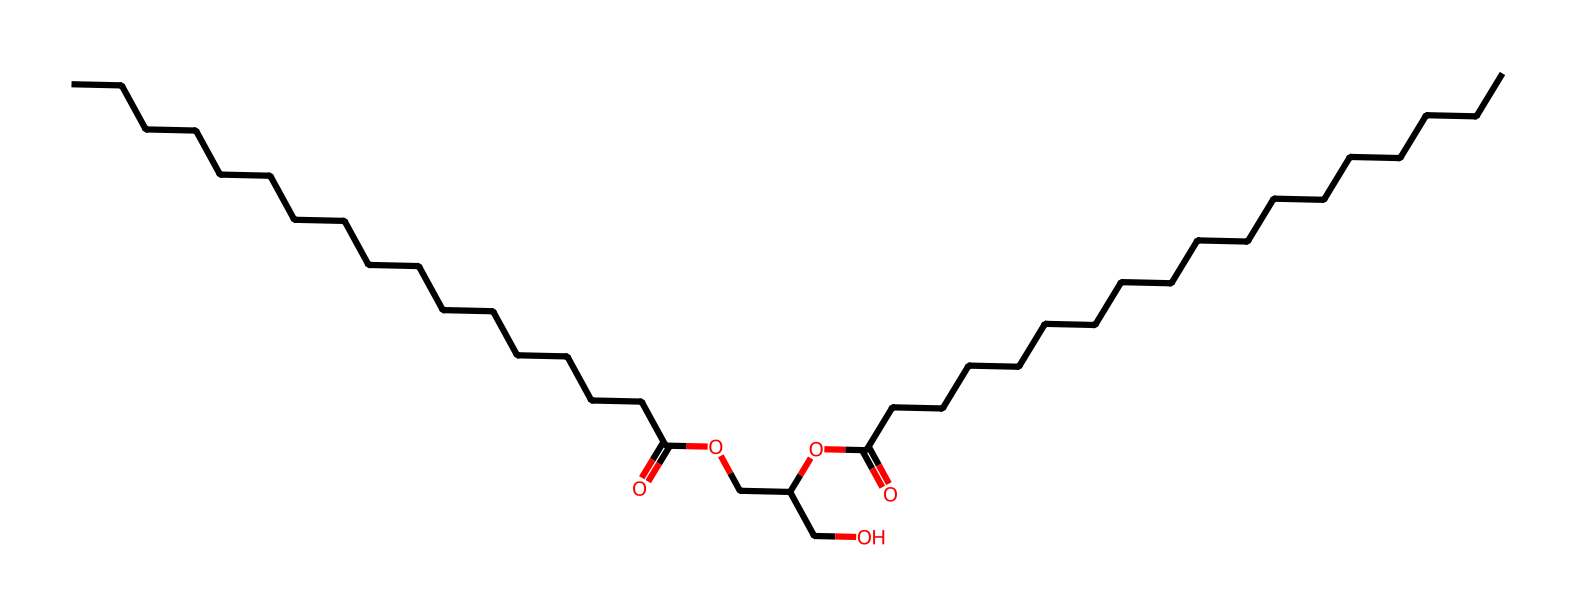What is the molecular formula of glyceryl stearate? To determine the molecular formula, we need to identify the number of each type of atom present in the SMILES representation. The structure reveals numerous carbon (C), hydrogen (H), and oxygen (O) atoms. By counting the specific atoms shown, we find there are 19 carbons, 36 hydrogens, and 4 oxygens. Hence, the molecular formula is C19H36O4.
Answer: C19H36O4 How many carbon atoms are in glyceryl stearate? Upon analyzing the SMILES representation, we can count the number of carbon atoms directly within the structure. The chemical representation clearly shows a total of 19 carbon atoms throughout its chains and branches.
Answer: 19 What type of chemical bond connects the carbon chains in glyceryl stearate? The carbon chains in glyceryl stearate predominantly involve single bonds. By examining the SMILES representation, we see that most of the carbon atoms are connected by single bonds (sigma bonds), with a few double bonds observed at carbonyl functional groups (C=O).
Answer: single bonds Is glyceryl stearate a saturated or unsaturated fatty acid derivative? Glyceryl stearate is derived from stearic acid, which has no double bonds in its fatty acid chain. The SMILES representation shows no instances of unsaturation (no double bonds in the carbon chain), confirming that it is a saturated fatty acid derivative.
Answer: saturated What functional groups are present in glyceryl stearate? In the chemical structure of glyceryl stearate, we see multiple functional groups represented. The presence of ester groups (-COO-) and hydroxyl groups (-OH) indicates these two types of functional groups are present. Therefore, we identify ester and alcohol functionalities.
Answer: ester, alcohol How does the structure of glyceryl stearate affect its properties as a surfactant? The structure features both hydrophobic carbon chains and hydrophilic hydroxyl and ester groups. This amphiphilic nature is key to surfactants, allowing them to reduce surface tension and stabilize emulsions. The balance of hydrophobic and hydrophilic parts gives glyceryl stearate the ability to function effectively in skincare products like sunscreens and moisturizers.
Answer: amphiphilic nature Why is glyceryl stearate used in sunscreens and moisturizers? Glyceryl stearate acts as an emulsifier and thickener due to its surfactant properties. The presence of both hydrophobic and hydrophilic components allows it to blend oil and water, stabilizing mixtures such as creams and lotions. This quality enhances moisture retention and protects the skin, making it ideal for personal care formulations.
Answer: emulsifier, thickener 